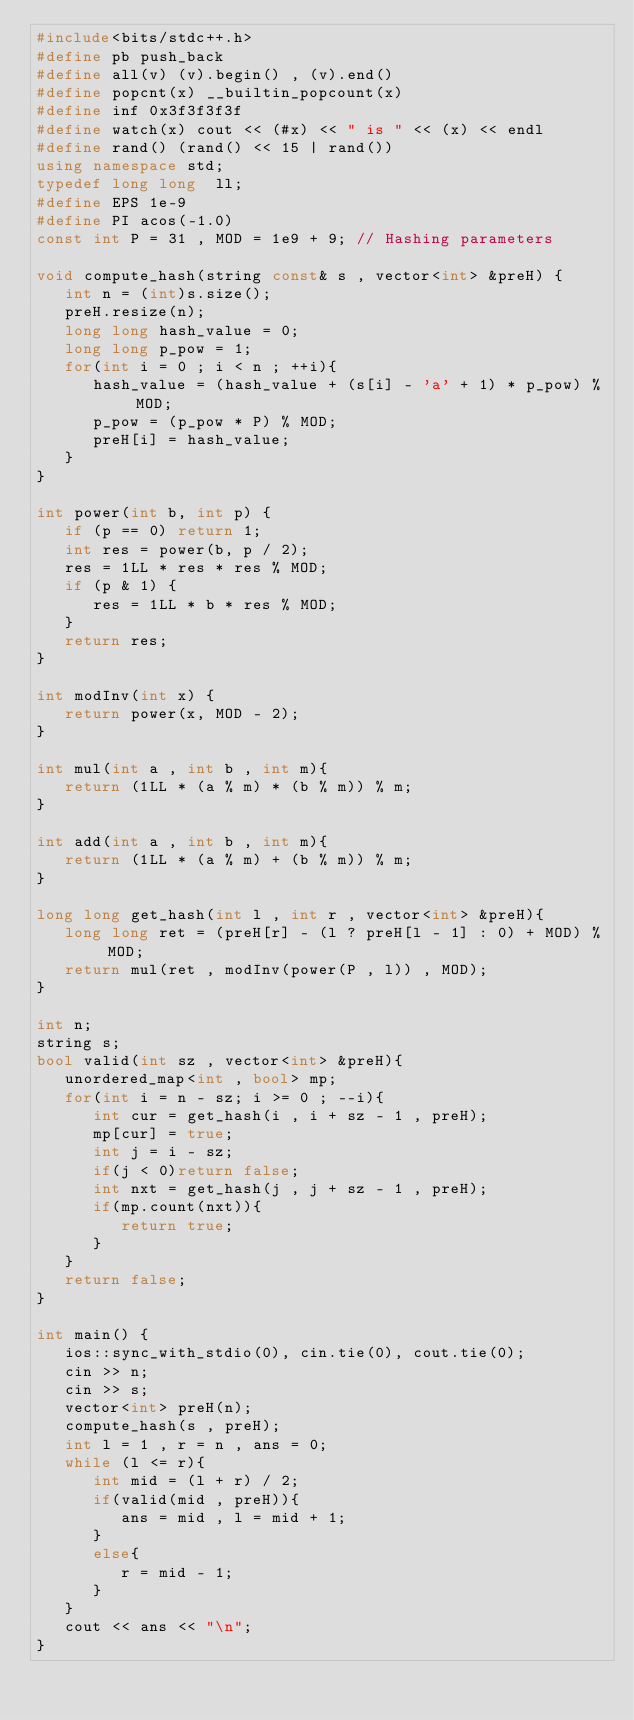<code> <loc_0><loc_0><loc_500><loc_500><_C++_>#include<bits/stdc++.h>
#define pb push_back
#define all(v) (v).begin() , (v).end()
#define popcnt(x) __builtin_popcount(x)
#define inf 0x3f3f3f3f
#define watch(x) cout << (#x) << " is " << (x) << endl
#define rand() (rand() << 15 | rand())
using namespace std;
typedef long long  ll;
#define EPS 1e-9
#define PI acos(-1.0)
const int P = 31 , MOD = 1e9 + 9; // Hashing parameters

void compute_hash(string const& s , vector<int> &preH) {
   int n = (int)s.size();
   preH.resize(n);
   long long hash_value = 0;
   long long p_pow = 1;
   for(int i = 0 ; i < n ; ++i){
      hash_value = (hash_value + (s[i] - 'a' + 1) * p_pow) % MOD;
      p_pow = (p_pow * P) % MOD;
      preH[i] = hash_value;
   }
}

int power(int b, int p) {
   if (p == 0) return 1;
   int res = power(b, p / 2);
   res = 1LL * res * res % MOD;
   if (p & 1) {
      res = 1LL * b * res % MOD;
   }
   return res;
}

int modInv(int x) {
   return power(x, MOD - 2);
}

int mul(int a , int b , int m){
   return (1LL * (a % m) * (b % m)) % m;
}

int add(int a , int b , int m){
   return (1LL * (a % m) + (b % m)) % m;
}

long long get_hash(int l , int r , vector<int> &preH){
   long long ret = (preH[r] - (l ? preH[l - 1] : 0) + MOD) % MOD;
   return mul(ret , modInv(power(P , l)) , MOD);
}

int n;
string s;
bool valid(int sz , vector<int> &preH){
   unordered_map<int , bool> mp;
   for(int i = n - sz; i >= 0 ; --i){
      int cur = get_hash(i , i + sz - 1 , preH);
      mp[cur] = true;
      int j = i - sz;
      if(j < 0)return false;
      int nxt = get_hash(j , j + sz - 1 , preH);
      if(mp.count(nxt)){
         return true;
      }
   }
   return false;
}

int main() {
   ios::sync_with_stdio(0), cin.tie(0), cout.tie(0);
   cin >> n;
   cin >> s;
   vector<int> preH(n);
   compute_hash(s , preH);
   int l = 1 , r = n , ans = 0;
   while (l <= r){
      int mid = (l + r) / 2;
      if(valid(mid , preH)){
         ans = mid , l = mid + 1;
      }
      else{
         r = mid - 1;
      }
   }
   cout << ans << "\n";
}</code> 